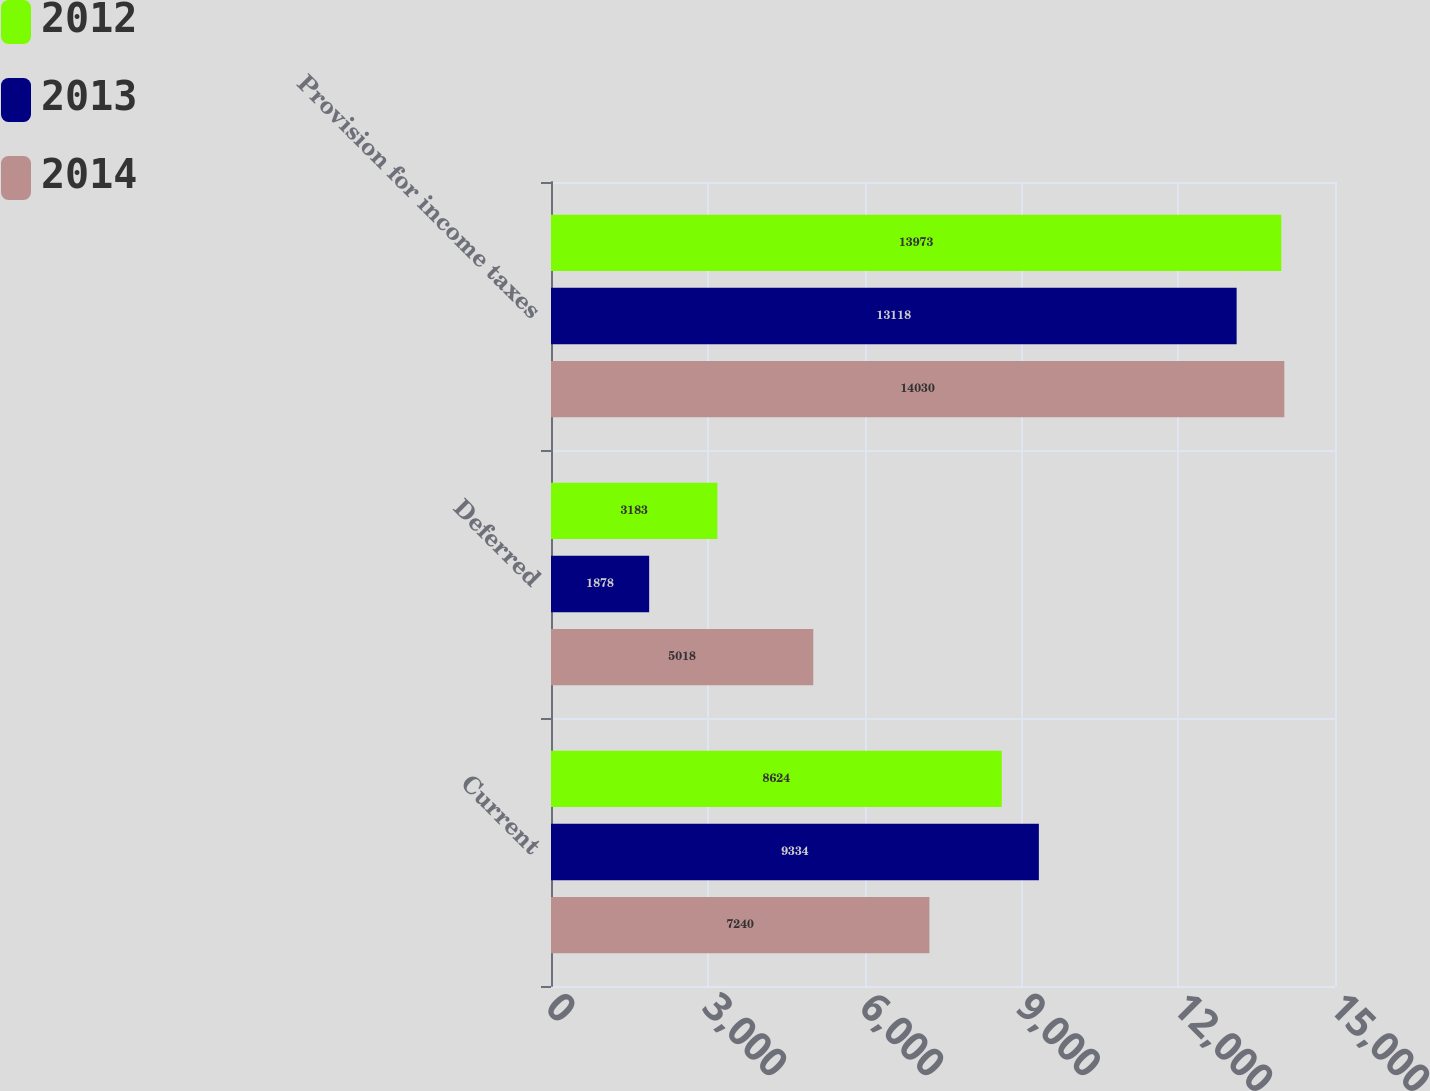<chart> <loc_0><loc_0><loc_500><loc_500><stacked_bar_chart><ecel><fcel>Current<fcel>Deferred<fcel>Provision for income taxes<nl><fcel>2012<fcel>8624<fcel>3183<fcel>13973<nl><fcel>2013<fcel>9334<fcel>1878<fcel>13118<nl><fcel>2014<fcel>7240<fcel>5018<fcel>14030<nl></chart> 